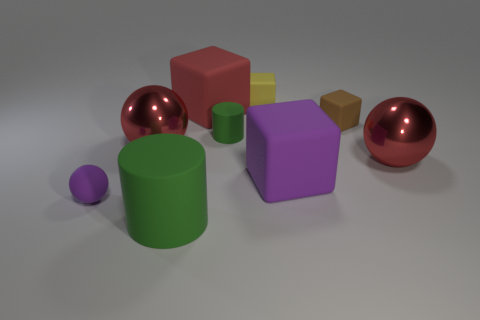The object that is the same color as the big cylinder is what size?
Offer a terse response. Small. Is the color of the big ball to the right of the small yellow rubber block the same as the tiny cylinder?
Your answer should be very brief. No. Is the number of small rubber cylinders that are in front of the tiny brown object greater than the number of tiny purple metal things?
Your answer should be very brief. Yes. What shape is the purple thing that is on the right side of the purple thing that is to the left of the small green rubber cylinder?
Give a very brief answer. Cube. Is the number of big green rubber objects greater than the number of big rubber balls?
Provide a succinct answer. Yes. What number of small objects are in front of the tiny brown rubber thing and right of the yellow thing?
Your answer should be very brief. 0. There is a big red ball right of the red rubber object; how many small brown matte blocks are left of it?
Provide a short and direct response. 1. How many things are green rubber objects that are in front of the large purple thing or small rubber objects that are left of the brown matte thing?
Your answer should be very brief. 4. There is a purple thing that is the same shape as the brown rubber object; what is it made of?
Give a very brief answer. Rubber. How many objects are either rubber blocks that are in front of the brown rubber object or tiny matte balls?
Your answer should be compact. 2. 